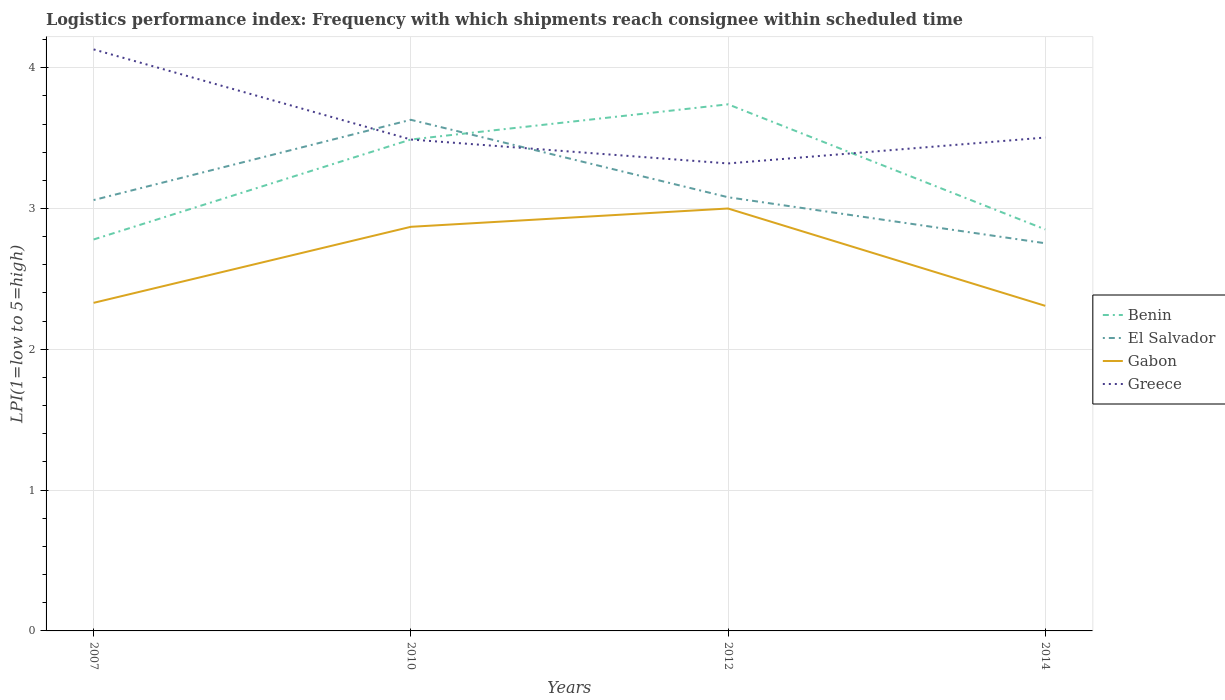Does the line corresponding to Greece intersect with the line corresponding to El Salvador?
Your answer should be compact. Yes. Is the number of lines equal to the number of legend labels?
Your response must be concise. Yes. Across all years, what is the maximum logistics performance index in Greece?
Your response must be concise. 3.32. In which year was the logistics performance index in Gabon maximum?
Offer a very short reply. 2014. What is the total logistics performance index in El Salvador in the graph?
Offer a very short reply. 0.88. What is the difference between the highest and the second highest logistics performance index in Benin?
Give a very brief answer. 0.96. How many lines are there?
Provide a succinct answer. 4. How many years are there in the graph?
Ensure brevity in your answer.  4. Does the graph contain grids?
Give a very brief answer. Yes. Where does the legend appear in the graph?
Provide a succinct answer. Center right. What is the title of the graph?
Ensure brevity in your answer.  Logistics performance index: Frequency with which shipments reach consignee within scheduled time. What is the label or title of the Y-axis?
Provide a short and direct response. LPI(1=low to 5=high). What is the LPI(1=low to 5=high) in Benin in 2007?
Provide a succinct answer. 2.78. What is the LPI(1=low to 5=high) of El Salvador in 2007?
Your answer should be very brief. 3.06. What is the LPI(1=low to 5=high) in Gabon in 2007?
Your response must be concise. 2.33. What is the LPI(1=low to 5=high) in Greece in 2007?
Provide a succinct answer. 4.13. What is the LPI(1=low to 5=high) of Benin in 2010?
Your response must be concise. 3.49. What is the LPI(1=low to 5=high) of El Salvador in 2010?
Ensure brevity in your answer.  3.63. What is the LPI(1=low to 5=high) of Gabon in 2010?
Give a very brief answer. 2.87. What is the LPI(1=low to 5=high) of Greece in 2010?
Offer a terse response. 3.49. What is the LPI(1=low to 5=high) of Benin in 2012?
Make the answer very short. 3.74. What is the LPI(1=low to 5=high) in El Salvador in 2012?
Ensure brevity in your answer.  3.08. What is the LPI(1=low to 5=high) of Greece in 2012?
Offer a very short reply. 3.32. What is the LPI(1=low to 5=high) of Benin in 2014?
Provide a succinct answer. 2.85. What is the LPI(1=low to 5=high) in El Salvador in 2014?
Your response must be concise. 2.75. What is the LPI(1=low to 5=high) of Gabon in 2014?
Give a very brief answer. 2.31. What is the LPI(1=low to 5=high) of Greece in 2014?
Make the answer very short. 3.5. Across all years, what is the maximum LPI(1=low to 5=high) of Benin?
Offer a very short reply. 3.74. Across all years, what is the maximum LPI(1=low to 5=high) in El Salvador?
Make the answer very short. 3.63. Across all years, what is the maximum LPI(1=low to 5=high) in Greece?
Provide a succinct answer. 4.13. Across all years, what is the minimum LPI(1=low to 5=high) of Benin?
Give a very brief answer. 2.78. Across all years, what is the minimum LPI(1=low to 5=high) of El Salvador?
Give a very brief answer. 2.75. Across all years, what is the minimum LPI(1=low to 5=high) in Gabon?
Your answer should be very brief. 2.31. Across all years, what is the minimum LPI(1=low to 5=high) in Greece?
Give a very brief answer. 3.32. What is the total LPI(1=low to 5=high) in Benin in the graph?
Your response must be concise. 12.86. What is the total LPI(1=low to 5=high) in El Salvador in the graph?
Ensure brevity in your answer.  12.52. What is the total LPI(1=low to 5=high) in Gabon in the graph?
Your answer should be very brief. 10.51. What is the total LPI(1=low to 5=high) in Greece in the graph?
Your response must be concise. 14.44. What is the difference between the LPI(1=low to 5=high) in Benin in 2007 and that in 2010?
Offer a terse response. -0.71. What is the difference between the LPI(1=low to 5=high) of El Salvador in 2007 and that in 2010?
Your response must be concise. -0.57. What is the difference between the LPI(1=low to 5=high) in Gabon in 2007 and that in 2010?
Make the answer very short. -0.54. What is the difference between the LPI(1=low to 5=high) of Greece in 2007 and that in 2010?
Keep it short and to the point. 0.64. What is the difference between the LPI(1=low to 5=high) in Benin in 2007 and that in 2012?
Give a very brief answer. -0.96. What is the difference between the LPI(1=low to 5=high) of El Salvador in 2007 and that in 2012?
Ensure brevity in your answer.  -0.02. What is the difference between the LPI(1=low to 5=high) of Gabon in 2007 and that in 2012?
Make the answer very short. -0.67. What is the difference between the LPI(1=low to 5=high) in Greece in 2007 and that in 2012?
Your response must be concise. 0.81. What is the difference between the LPI(1=low to 5=high) of Benin in 2007 and that in 2014?
Give a very brief answer. -0.07. What is the difference between the LPI(1=low to 5=high) of El Salvador in 2007 and that in 2014?
Your answer should be compact. 0.31. What is the difference between the LPI(1=low to 5=high) in Gabon in 2007 and that in 2014?
Provide a short and direct response. 0.02. What is the difference between the LPI(1=low to 5=high) in Greece in 2007 and that in 2014?
Your answer should be very brief. 0.63. What is the difference between the LPI(1=low to 5=high) of El Salvador in 2010 and that in 2012?
Your answer should be very brief. 0.55. What is the difference between the LPI(1=low to 5=high) in Gabon in 2010 and that in 2012?
Provide a short and direct response. -0.13. What is the difference between the LPI(1=low to 5=high) of Greece in 2010 and that in 2012?
Provide a short and direct response. 0.17. What is the difference between the LPI(1=low to 5=high) of Benin in 2010 and that in 2014?
Offer a terse response. 0.64. What is the difference between the LPI(1=low to 5=high) of El Salvador in 2010 and that in 2014?
Offer a very short reply. 0.88. What is the difference between the LPI(1=low to 5=high) of Gabon in 2010 and that in 2014?
Give a very brief answer. 0.56. What is the difference between the LPI(1=low to 5=high) in Greece in 2010 and that in 2014?
Provide a succinct answer. -0.01. What is the difference between the LPI(1=low to 5=high) in Benin in 2012 and that in 2014?
Your response must be concise. 0.89. What is the difference between the LPI(1=low to 5=high) in El Salvador in 2012 and that in 2014?
Offer a terse response. 0.33. What is the difference between the LPI(1=low to 5=high) of Gabon in 2012 and that in 2014?
Your response must be concise. 0.69. What is the difference between the LPI(1=low to 5=high) in Greece in 2012 and that in 2014?
Ensure brevity in your answer.  -0.18. What is the difference between the LPI(1=low to 5=high) of Benin in 2007 and the LPI(1=low to 5=high) of El Salvador in 2010?
Ensure brevity in your answer.  -0.85. What is the difference between the LPI(1=low to 5=high) in Benin in 2007 and the LPI(1=low to 5=high) in Gabon in 2010?
Your answer should be compact. -0.09. What is the difference between the LPI(1=low to 5=high) of Benin in 2007 and the LPI(1=low to 5=high) of Greece in 2010?
Offer a terse response. -0.71. What is the difference between the LPI(1=low to 5=high) in El Salvador in 2007 and the LPI(1=low to 5=high) in Gabon in 2010?
Your answer should be very brief. 0.19. What is the difference between the LPI(1=low to 5=high) in El Salvador in 2007 and the LPI(1=low to 5=high) in Greece in 2010?
Make the answer very short. -0.43. What is the difference between the LPI(1=low to 5=high) of Gabon in 2007 and the LPI(1=low to 5=high) of Greece in 2010?
Keep it short and to the point. -1.16. What is the difference between the LPI(1=low to 5=high) of Benin in 2007 and the LPI(1=low to 5=high) of El Salvador in 2012?
Your answer should be very brief. -0.3. What is the difference between the LPI(1=low to 5=high) of Benin in 2007 and the LPI(1=low to 5=high) of Gabon in 2012?
Ensure brevity in your answer.  -0.22. What is the difference between the LPI(1=low to 5=high) of Benin in 2007 and the LPI(1=low to 5=high) of Greece in 2012?
Keep it short and to the point. -0.54. What is the difference between the LPI(1=low to 5=high) in El Salvador in 2007 and the LPI(1=low to 5=high) in Greece in 2012?
Provide a short and direct response. -0.26. What is the difference between the LPI(1=low to 5=high) of Gabon in 2007 and the LPI(1=low to 5=high) of Greece in 2012?
Your answer should be compact. -0.99. What is the difference between the LPI(1=low to 5=high) of Benin in 2007 and the LPI(1=low to 5=high) of El Salvador in 2014?
Provide a succinct answer. 0.03. What is the difference between the LPI(1=low to 5=high) of Benin in 2007 and the LPI(1=low to 5=high) of Gabon in 2014?
Your answer should be compact. 0.47. What is the difference between the LPI(1=low to 5=high) of Benin in 2007 and the LPI(1=low to 5=high) of Greece in 2014?
Your answer should be very brief. -0.72. What is the difference between the LPI(1=low to 5=high) in El Salvador in 2007 and the LPI(1=low to 5=high) in Gabon in 2014?
Offer a very short reply. 0.75. What is the difference between the LPI(1=low to 5=high) in El Salvador in 2007 and the LPI(1=low to 5=high) in Greece in 2014?
Offer a terse response. -0.44. What is the difference between the LPI(1=low to 5=high) of Gabon in 2007 and the LPI(1=low to 5=high) of Greece in 2014?
Offer a terse response. -1.17. What is the difference between the LPI(1=low to 5=high) in Benin in 2010 and the LPI(1=low to 5=high) in El Salvador in 2012?
Your response must be concise. 0.41. What is the difference between the LPI(1=low to 5=high) of Benin in 2010 and the LPI(1=low to 5=high) of Gabon in 2012?
Make the answer very short. 0.49. What is the difference between the LPI(1=low to 5=high) in Benin in 2010 and the LPI(1=low to 5=high) in Greece in 2012?
Your response must be concise. 0.17. What is the difference between the LPI(1=low to 5=high) in El Salvador in 2010 and the LPI(1=low to 5=high) in Gabon in 2012?
Keep it short and to the point. 0.63. What is the difference between the LPI(1=low to 5=high) of El Salvador in 2010 and the LPI(1=low to 5=high) of Greece in 2012?
Ensure brevity in your answer.  0.31. What is the difference between the LPI(1=low to 5=high) of Gabon in 2010 and the LPI(1=low to 5=high) of Greece in 2012?
Provide a succinct answer. -0.45. What is the difference between the LPI(1=low to 5=high) in Benin in 2010 and the LPI(1=low to 5=high) in El Salvador in 2014?
Give a very brief answer. 0.74. What is the difference between the LPI(1=low to 5=high) in Benin in 2010 and the LPI(1=low to 5=high) in Gabon in 2014?
Offer a very short reply. 1.18. What is the difference between the LPI(1=low to 5=high) in Benin in 2010 and the LPI(1=low to 5=high) in Greece in 2014?
Give a very brief answer. -0.01. What is the difference between the LPI(1=low to 5=high) of El Salvador in 2010 and the LPI(1=low to 5=high) of Gabon in 2014?
Your answer should be very brief. 1.32. What is the difference between the LPI(1=low to 5=high) in El Salvador in 2010 and the LPI(1=low to 5=high) in Greece in 2014?
Ensure brevity in your answer.  0.13. What is the difference between the LPI(1=low to 5=high) of Gabon in 2010 and the LPI(1=low to 5=high) of Greece in 2014?
Your answer should be very brief. -0.63. What is the difference between the LPI(1=low to 5=high) of Benin in 2012 and the LPI(1=low to 5=high) of El Salvador in 2014?
Your response must be concise. 0.99. What is the difference between the LPI(1=low to 5=high) of Benin in 2012 and the LPI(1=low to 5=high) of Gabon in 2014?
Offer a very short reply. 1.43. What is the difference between the LPI(1=low to 5=high) in Benin in 2012 and the LPI(1=low to 5=high) in Greece in 2014?
Provide a short and direct response. 0.24. What is the difference between the LPI(1=low to 5=high) in El Salvador in 2012 and the LPI(1=low to 5=high) in Gabon in 2014?
Provide a succinct answer. 0.77. What is the difference between the LPI(1=low to 5=high) in El Salvador in 2012 and the LPI(1=low to 5=high) in Greece in 2014?
Give a very brief answer. -0.42. What is the difference between the LPI(1=low to 5=high) in Gabon in 2012 and the LPI(1=low to 5=high) in Greece in 2014?
Offer a terse response. -0.5. What is the average LPI(1=low to 5=high) in Benin per year?
Give a very brief answer. 3.22. What is the average LPI(1=low to 5=high) in El Salvador per year?
Ensure brevity in your answer.  3.13. What is the average LPI(1=low to 5=high) of Gabon per year?
Give a very brief answer. 2.63. What is the average LPI(1=low to 5=high) in Greece per year?
Offer a very short reply. 3.61. In the year 2007, what is the difference between the LPI(1=low to 5=high) in Benin and LPI(1=low to 5=high) in El Salvador?
Your answer should be very brief. -0.28. In the year 2007, what is the difference between the LPI(1=low to 5=high) of Benin and LPI(1=low to 5=high) of Gabon?
Give a very brief answer. 0.45. In the year 2007, what is the difference between the LPI(1=low to 5=high) in Benin and LPI(1=low to 5=high) in Greece?
Your answer should be compact. -1.35. In the year 2007, what is the difference between the LPI(1=low to 5=high) in El Salvador and LPI(1=low to 5=high) in Gabon?
Offer a terse response. 0.73. In the year 2007, what is the difference between the LPI(1=low to 5=high) in El Salvador and LPI(1=low to 5=high) in Greece?
Give a very brief answer. -1.07. In the year 2007, what is the difference between the LPI(1=low to 5=high) in Gabon and LPI(1=low to 5=high) in Greece?
Offer a very short reply. -1.8. In the year 2010, what is the difference between the LPI(1=low to 5=high) in Benin and LPI(1=low to 5=high) in El Salvador?
Keep it short and to the point. -0.14. In the year 2010, what is the difference between the LPI(1=low to 5=high) in Benin and LPI(1=low to 5=high) in Gabon?
Ensure brevity in your answer.  0.62. In the year 2010, what is the difference between the LPI(1=low to 5=high) in Benin and LPI(1=low to 5=high) in Greece?
Your response must be concise. 0. In the year 2010, what is the difference between the LPI(1=low to 5=high) of El Salvador and LPI(1=low to 5=high) of Gabon?
Give a very brief answer. 0.76. In the year 2010, what is the difference between the LPI(1=low to 5=high) of El Salvador and LPI(1=low to 5=high) of Greece?
Give a very brief answer. 0.14. In the year 2010, what is the difference between the LPI(1=low to 5=high) in Gabon and LPI(1=low to 5=high) in Greece?
Offer a very short reply. -0.62. In the year 2012, what is the difference between the LPI(1=low to 5=high) of Benin and LPI(1=low to 5=high) of El Salvador?
Offer a terse response. 0.66. In the year 2012, what is the difference between the LPI(1=low to 5=high) in Benin and LPI(1=low to 5=high) in Gabon?
Make the answer very short. 0.74. In the year 2012, what is the difference between the LPI(1=low to 5=high) of Benin and LPI(1=low to 5=high) of Greece?
Ensure brevity in your answer.  0.42. In the year 2012, what is the difference between the LPI(1=low to 5=high) of El Salvador and LPI(1=low to 5=high) of Greece?
Ensure brevity in your answer.  -0.24. In the year 2012, what is the difference between the LPI(1=low to 5=high) of Gabon and LPI(1=low to 5=high) of Greece?
Make the answer very short. -0.32. In the year 2014, what is the difference between the LPI(1=low to 5=high) of Benin and LPI(1=low to 5=high) of El Salvador?
Your response must be concise. 0.1. In the year 2014, what is the difference between the LPI(1=low to 5=high) of Benin and LPI(1=low to 5=high) of Gabon?
Keep it short and to the point. 0.54. In the year 2014, what is the difference between the LPI(1=low to 5=high) in Benin and LPI(1=low to 5=high) in Greece?
Offer a terse response. -0.65. In the year 2014, what is the difference between the LPI(1=low to 5=high) in El Salvador and LPI(1=low to 5=high) in Gabon?
Ensure brevity in your answer.  0.44. In the year 2014, what is the difference between the LPI(1=low to 5=high) in El Salvador and LPI(1=low to 5=high) in Greece?
Your answer should be compact. -0.75. In the year 2014, what is the difference between the LPI(1=low to 5=high) of Gabon and LPI(1=low to 5=high) of Greece?
Offer a very short reply. -1.2. What is the ratio of the LPI(1=low to 5=high) of Benin in 2007 to that in 2010?
Ensure brevity in your answer.  0.8. What is the ratio of the LPI(1=low to 5=high) of El Salvador in 2007 to that in 2010?
Your answer should be compact. 0.84. What is the ratio of the LPI(1=low to 5=high) in Gabon in 2007 to that in 2010?
Your response must be concise. 0.81. What is the ratio of the LPI(1=low to 5=high) of Greece in 2007 to that in 2010?
Your answer should be very brief. 1.18. What is the ratio of the LPI(1=low to 5=high) in Benin in 2007 to that in 2012?
Your answer should be compact. 0.74. What is the ratio of the LPI(1=low to 5=high) of El Salvador in 2007 to that in 2012?
Provide a succinct answer. 0.99. What is the ratio of the LPI(1=low to 5=high) of Gabon in 2007 to that in 2012?
Your answer should be compact. 0.78. What is the ratio of the LPI(1=low to 5=high) of Greece in 2007 to that in 2012?
Ensure brevity in your answer.  1.24. What is the ratio of the LPI(1=low to 5=high) of Benin in 2007 to that in 2014?
Your answer should be compact. 0.97. What is the ratio of the LPI(1=low to 5=high) of El Salvador in 2007 to that in 2014?
Offer a very short reply. 1.11. What is the ratio of the LPI(1=low to 5=high) in Gabon in 2007 to that in 2014?
Your answer should be very brief. 1.01. What is the ratio of the LPI(1=low to 5=high) in Greece in 2007 to that in 2014?
Offer a terse response. 1.18. What is the ratio of the LPI(1=low to 5=high) of Benin in 2010 to that in 2012?
Offer a terse response. 0.93. What is the ratio of the LPI(1=low to 5=high) in El Salvador in 2010 to that in 2012?
Your response must be concise. 1.18. What is the ratio of the LPI(1=low to 5=high) in Gabon in 2010 to that in 2012?
Offer a terse response. 0.96. What is the ratio of the LPI(1=low to 5=high) in Greece in 2010 to that in 2012?
Your response must be concise. 1.05. What is the ratio of the LPI(1=low to 5=high) in Benin in 2010 to that in 2014?
Ensure brevity in your answer.  1.22. What is the ratio of the LPI(1=low to 5=high) of El Salvador in 2010 to that in 2014?
Give a very brief answer. 1.32. What is the ratio of the LPI(1=low to 5=high) in Gabon in 2010 to that in 2014?
Provide a short and direct response. 1.24. What is the ratio of the LPI(1=low to 5=high) in Benin in 2012 to that in 2014?
Provide a short and direct response. 1.31. What is the ratio of the LPI(1=low to 5=high) of El Salvador in 2012 to that in 2014?
Keep it short and to the point. 1.12. What is the ratio of the LPI(1=low to 5=high) of Gabon in 2012 to that in 2014?
Ensure brevity in your answer.  1.3. What is the ratio of the LPI(1=low to 5=high) in Greece in 2012 to that in 2014?
Make the answer very short. 0.95. What is the difference between the highest and the second highest LPI(1=low to 5=high) in El Salvador?
Offer a very short reply. 0.55. What is the difference between the highest and the second highest LPI(1=low to 5=high) of Gabon?
Make the answer very short. 0.13. What is the difference between the highest and the second highest LPI(1=low to 5=high) of Greece?
Provide a succinct answer. 0.63. What is the difference between the highest and the lowest LPI(1=low to 5=high) of El Salvador?
Your answer should be compact. 0.88. What is the difference between the highest and the lowest LPI(1=low to 5=high) of Gabon?
Offer a very short reply. 0.69. What is the difference between the highest and the lowest LPI(1=low to 5=high) of Greece?
Provide a short and direct response. 0.81. 